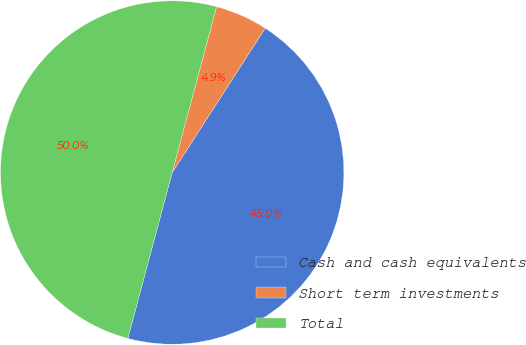Convert chart. <chart><loc_0><loc_0><loc_500><loc_500><pie_chart><fcel>Cash and cash equivalents<fcel>Short term investments<fcel>Total<nl><fcel>45.05%<fcel>4.95%<fcel>50.0%<nl></chart> 